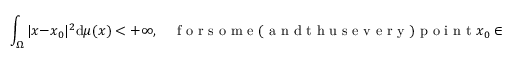<formula> <loc_0><loc_0><loc_500><loc_500>\int _ { \Omega } | x - x _ { 0 } | ^ { 2 } d \mu ( x ) < + \infty , \quad f o r s o m e ( a n d t h u s e v e r y ) p o i n t x _ { 0 } \in \Omega .</formula> 